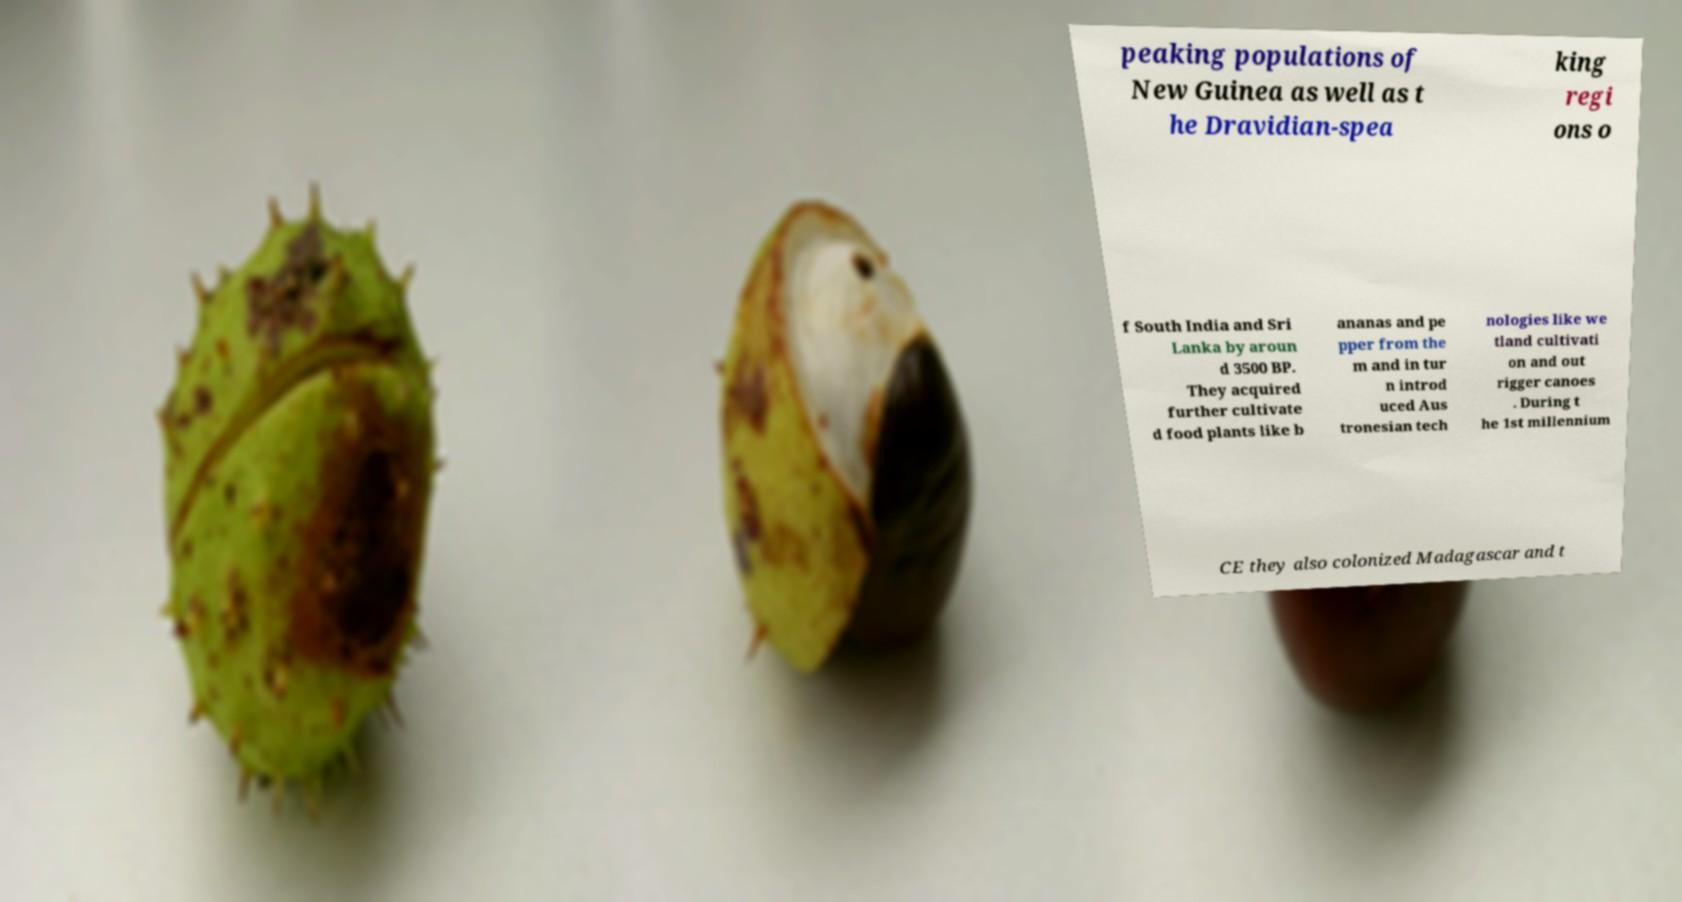Please identify and transcribe the text found in this image. peaking populations of New Guinea as well as t he Dravidian-spea king regi ons o f South India and Sri Lanka by aroun d 3500 BP. They acquired further cultivate d food plants like b ananas and pe pper from the m and in tur n introd uced Aus tronesian tech nologies like we tland cultivati on and out rigger canoes . During t he 1st millennium CE they also colonized Madagascar and t 